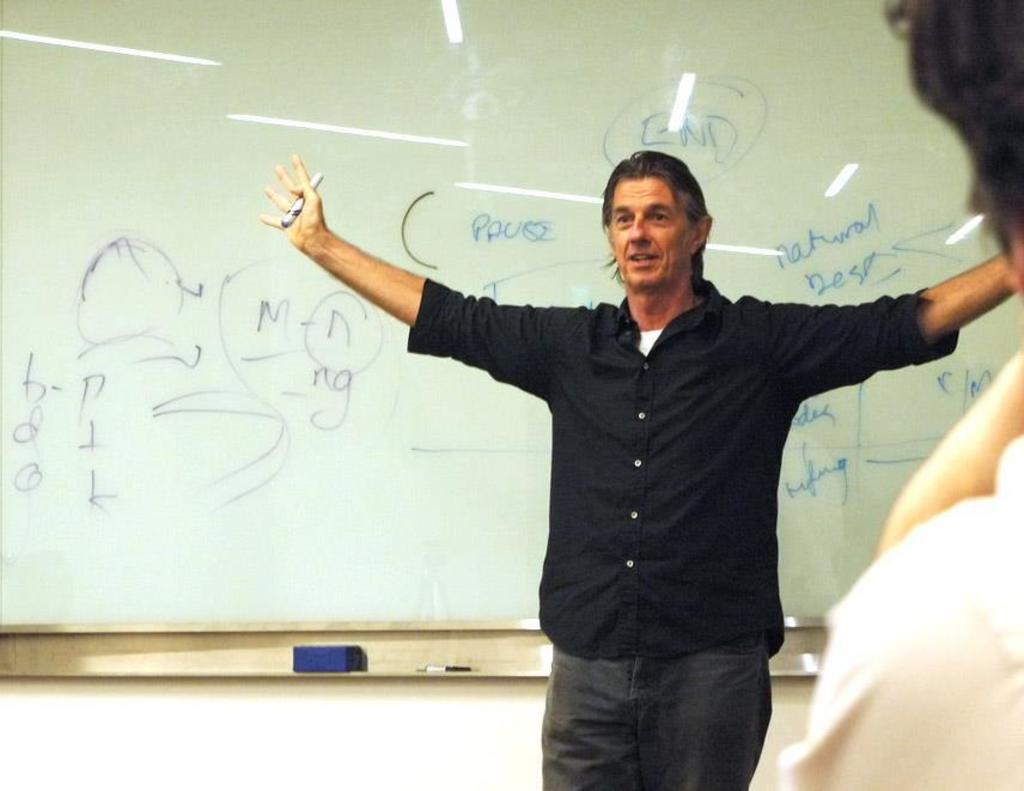<image>
Render a clear and concise summary of the photo. an instructor stands with wide open arms in front of a whiteboard with words like PAUSE on it 